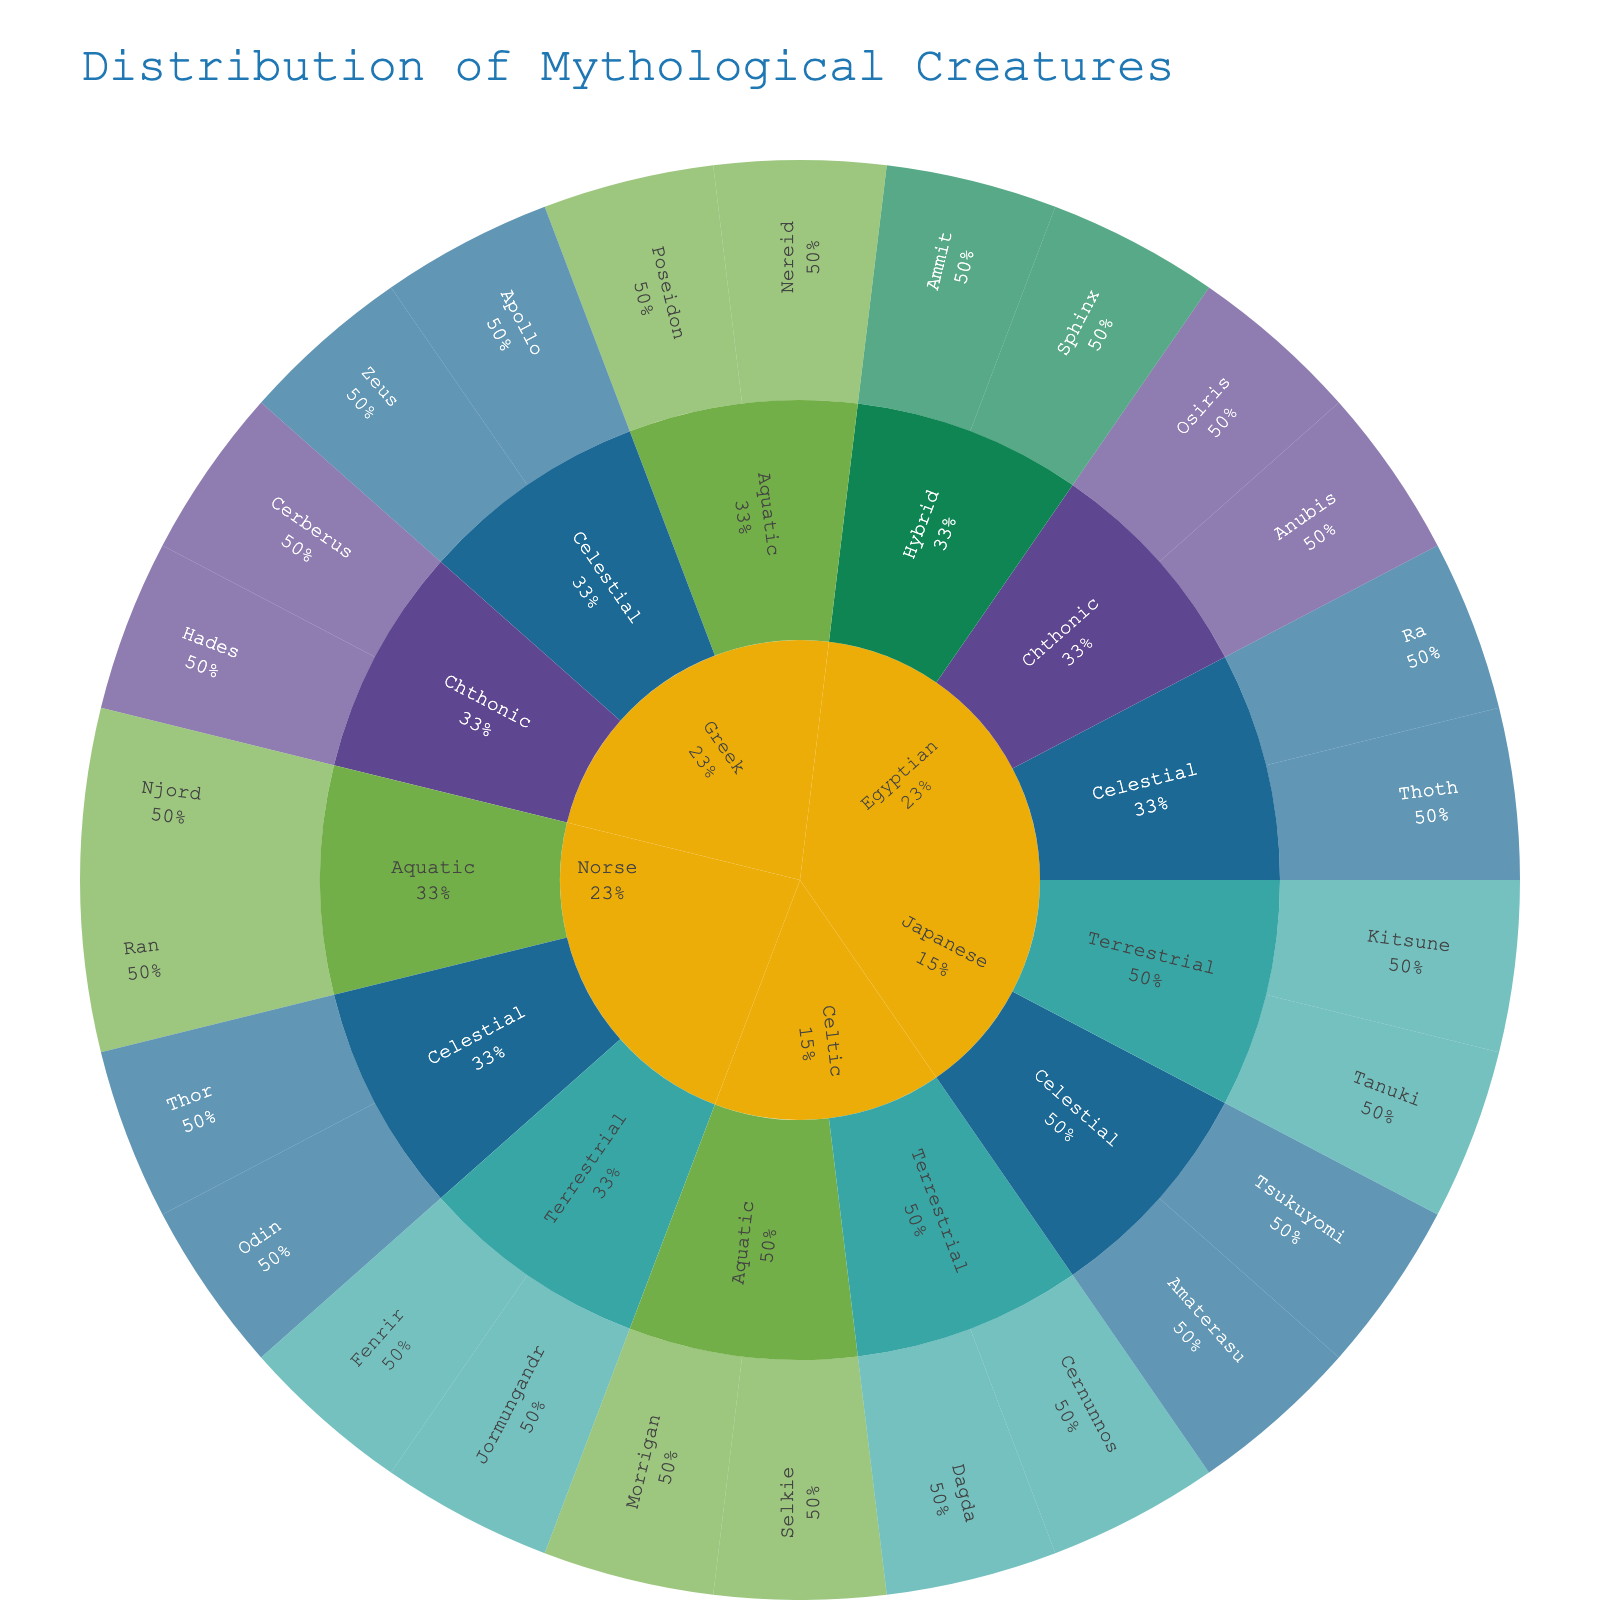What is the title of the sunburst plot? The title of the plot is displayed at the top in a larger font size. It provides the main context for what the visualization is about. Simply refer to the obvious text displayed at the top.
Answer: Distribution of Mythological Creatures Which category has the most creatures in Greek mythology? Look at the Greek segment in the sunburst plot and observe the size of the arcs for the categories Celestial, Aquatic, and Chthonic. The category with the largest single arc has the most creatures.
Answer: Celestial How many creatures are represented under the Celestial category for the Greek origin? Click or hover over the Celestial arc within the Greek segment to see the list of creatures and count them.
Answer: 2 (Zeus and Apollo) Which mythological origin has the most categories represented? Look through each origin (Greek, Norse, Egyptian, Celtic, Japanese) and count the unique categories within each segment. The origin with the highest count of categories is the answer.
Answer: Egyptian and Japanese (each have 3 categories) Compare the number of terrestrial creatures in Norse and Celtic mythology. Which has more? Identify the Terrestrial arcs within the Norse and Celtic segments. Count the creatures under each and compare the numbers directly.
Answer: Norse (2 creatures) has more than Celtic (2 creatures) What attribute is most commonly found in the Aquatic category across all mythologies? Examine the Aquatic sections in each origin and list their attributes. The attribute that appears most frequently among these sections is the answer.
Answer: Sea (found in Greek and Norse) Which origin features a unique category not shared with any other origin? Compare categories across all origins and identify any category that appears exclusively in one origin.
Answer: Egyptian (Hybrid is unique to Egyptian) For the Japanese origin, which celestial creature is associated with the Sun? Mindfully inspect the Japanese segment, specifically the Celestial arc. Identify the creature listed under the Sun attribute.
Answer: Amaterasu What is the total number of creatures represented in the plot? Count every creature present in each segment of the sunburst plot across all origins and categories.
Answer: 26 creatures Which category in the Egyptian origin includes a creature associated with Riddles? Navigate to the Egyptian segment and inspect each category to find the attribute 'Riddles' and identify its corresponding category.
Answer: Hybrid 